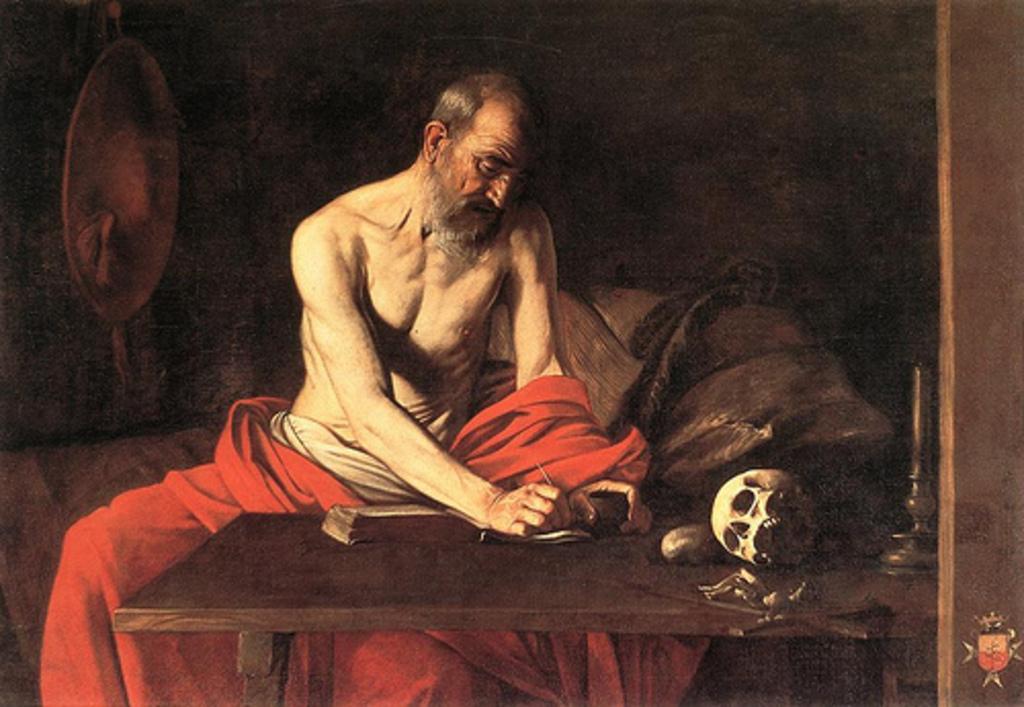In one or two sentences, can you explain what this image depicts? In the picture we can see a painting of a man sitting near the table and doing something with a needle and on the table we can see a skull and some bones and a candle on candle stand and behind him we can see a wall with a mirror on it. 